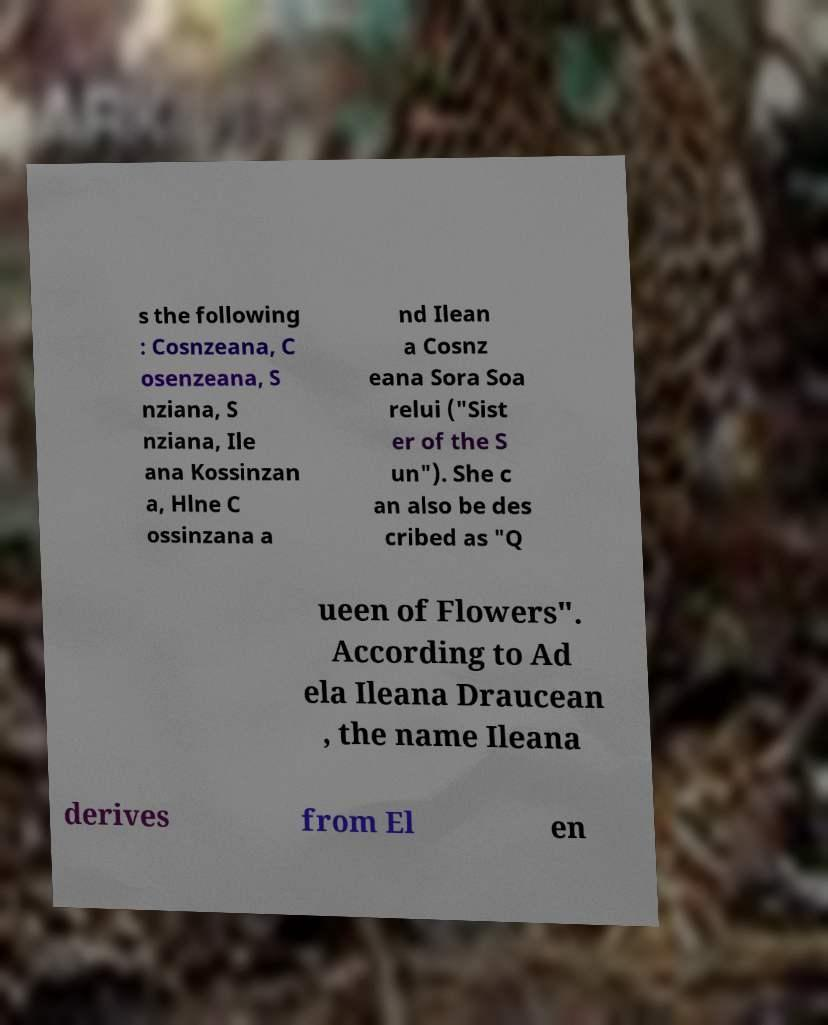Could you assist in decoding the text presented in this image and type it out clearly? s the following : Cosnzeana, C osenzeana, S nziana, S nziana, Ile ana Kossinzan a, Hlne C ossinzana a nd Ilean a Cosnz eana Sora Soa relui ("Sist er of the S un"). She c an also be des cribed as "Q ueen of Flowers". According to Ad ela Ileana Draucean , the name Ileana derives from El en 